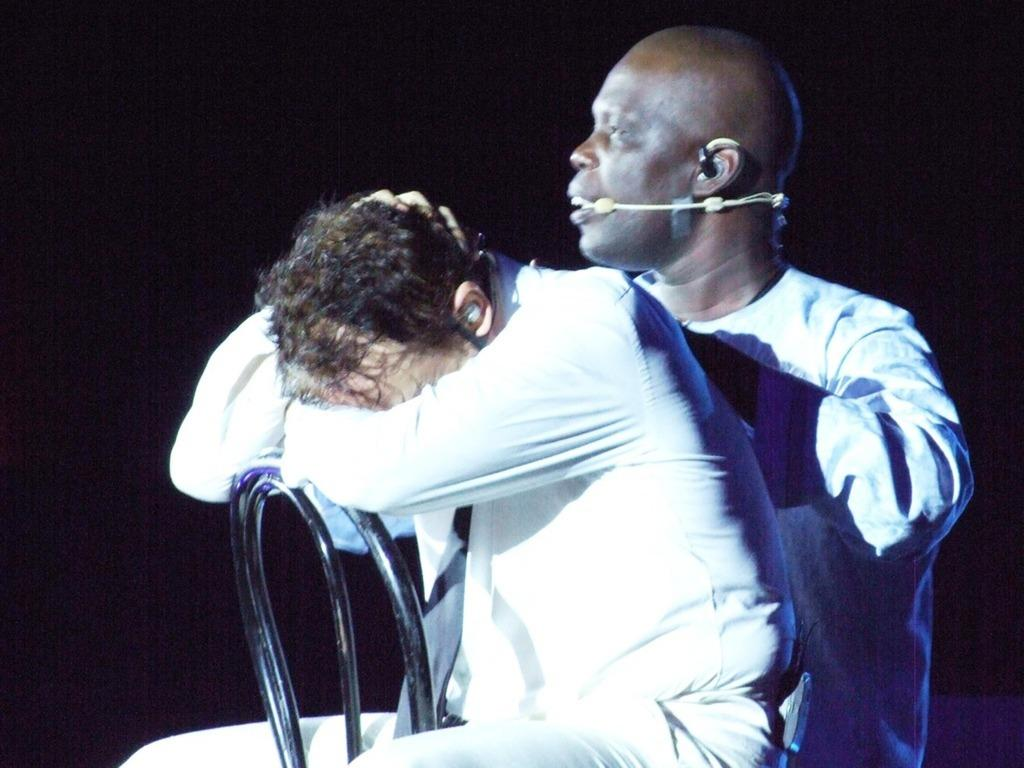How many people are in the image? There are two persons in the image. What are the persons doing in the image? Both persons are sitting on chairs. Can you describe any specific accessory worn by one of the persons? One of the persons is wearing a headset microphone. What is the color of the background in the image? The background of the image is dark. What type of steel is used to construct the boat in the image? There is no boat present in the image, and therefore no steel can be associated with it. 